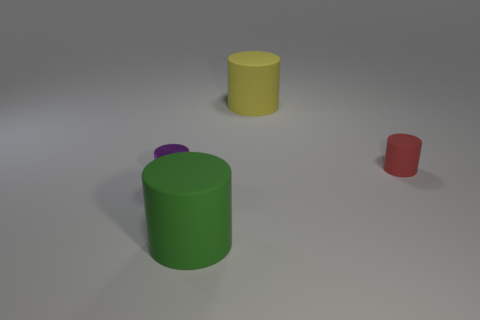Subtract all matte cylinders. How many cylinders are left? 1 Subtract all brown cylinders. Subtract all gray blocks. How many cylinders are left? 4 Add 3 red matte cylinders. How many objects exist? 7 Add 2 green cylinders. How many green cylinders are left? 3 Add 3 red rubber objects. How many red rubber objects exist? 4 Subtract 1 purple cylinders. How many objects are left? 3 Subtract all small brown matte things. Subtract all tiny purple metallic things. How many objects are left? 3 